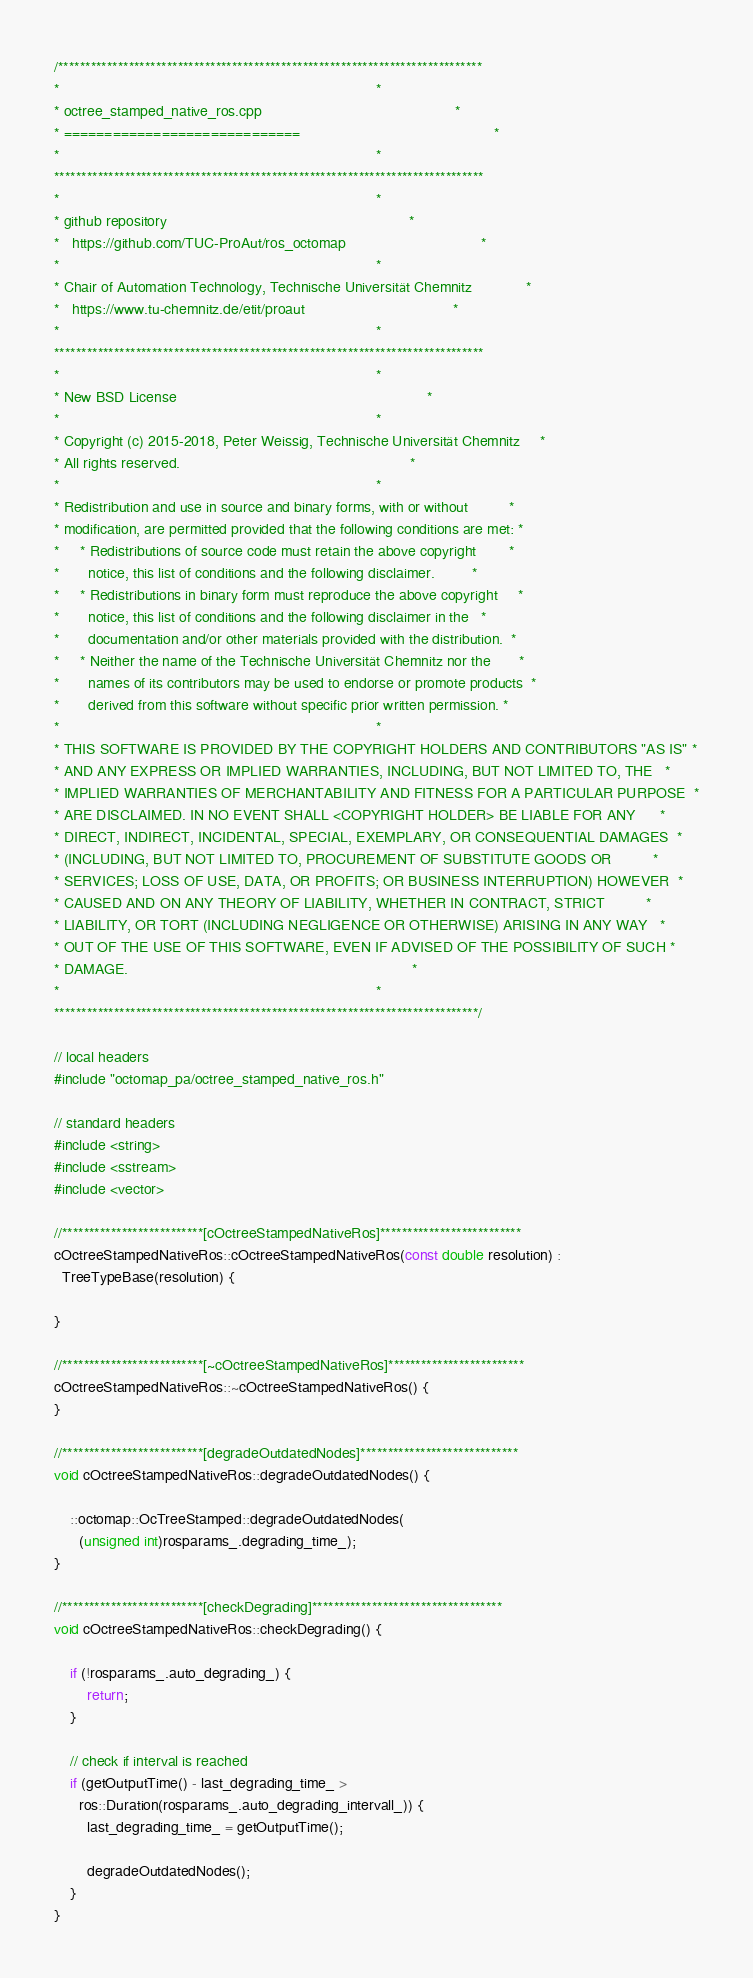<code> <loc_0><loc_0><loc_500><loc_500><_C++_>/******************************************************************************
*                                                                             *
* octree_stamped_native_ros.cpp                                               *
* =============================                                               *
*                                                                             *
*******************************************************************************
*                                                                             *
* github repository                                                           *
*   https://github.com/TUC-ProAut/ros_octomap                                 *
*                                                                             *
* Chair of Automation Technology, Technische Universität Chemnitz             *
*   https://www.tu-chemnitz.de/etit/proaut                                    *
*                                                                             *
*******************************************************************************
*                                                                             *
* New BSD License                                                             *
*                                                                             *
* Copyright (c) 2015-2018, Peter Weissig, Technische Universität Chemnitz     *
* All rights reserved.                                                        *
*                                                                             *
* Redistribution and use in source and binary forms, with or without          *
* modification, are permitted provided that the following conditions are met: *
*     * Redistributions of source code must retain the above copyright        *
*       notice, this list of conditions and the following disclaimer.         *
*     * Redistributions in binary form must reproduce the above copyright     *
*       notice, this list of conditions and the following disclaimer in the   *
*       documentation and/or other materials provided with the distribution.  *
*     * Neither the name of the Technische Universität Chemnitz nor the       *
*       names of its contributors may be used to endorse or promote products  *
*       derived from this software without specific prior written permission. *
*                                                                             *
* THIS SOFTWARE IS PROVIDED BY THE COPYRIGHT HOLDERS AND CONTRIBUTORS "AS IS" *
* AND ANY EXPRESS OR IMPLIED WARRANTIES, INCLUDING, BUT NOT LIMITED TO, THE   *
* IMPLIED WARRANTIES OF MERCHANTABILITY AND FITNESS FOR A PARTICULAR PURPOSE  *
* ARE DISCLAIMED. IN NO EVENT SHALL <COPYRIGHT HOLDER> BE LIABLE FOR ANY      *
* DIRECT, INDIRECT, INCIDENTAL, SPECIAL, EXEMPLARY, OR CONSEQUENTIAL DAMAGES  *
* (INCLUDING, BUT NOT LIMITED TO, PROCUREMENT OF SUBSTITUTE GOODS OR          *
* SERVICES; LOSS OF USE, DATA, OR PROFITS; OR BUSINESS INTERRUPTION) HOWEVER  *
* CAUSED AND ON ANY THEORY OF LIABILITY, WHETHER IN CONTRACT, STRICT          *
* LIABILITY, OR TORT (INCLUDING NEGLIGENCE OR OTHERWISE) ARISING IN ANY WAY   *
* OUT OF THE USE OF THIS SOFTWARE, EVEN IF ADVISED OF THE POSSIBILITY OF SUCH *
* DAMAGE.                                                                     *
*                                                                             *
******************************************************************************/

// local headers
#include "octomap_pa/octree_stamped_native_ros.h"

// standard headers
#include <string>
#include <sstream>
#include <vector>

//**************************[cOctreeStampedNativeRos]**************************
cOctreeStampedNativeRos::cOctreeStampedNativeRos(const double resolution) :
  TreeTypeBase(resolution) {

}

//**************************[~cOctreeStampedNativeRos]*************************
cOctreeStampedNativeRos::~cOctreeStampedNativeRos() {
}

//**************************[degradeOutdatedNodes]*****************************
void cOctreeStampedNativeRos::degradeOutdatedNodes() {

    ::octomap::OcTreeStamped::degradeOutdatedNodes(
      (unsigned int)rosparams_.degrading_time_);
}

//**************************[checkDegrading]***********************************
void cOctreeStampedNativeRos::checkDegrading() {

    if (!rosparams_.auto_degrading_) {
        return;
    }

    // check if interval is reached
    if (getOutputTime() - last_degrading_time_ >
      ros::Duration(rosparams_.auto_degrading_intervall_)) {
        last_degrading_time_ = getOutputTime();

        degradeOutdatedNodes();
    }
}
</code> 